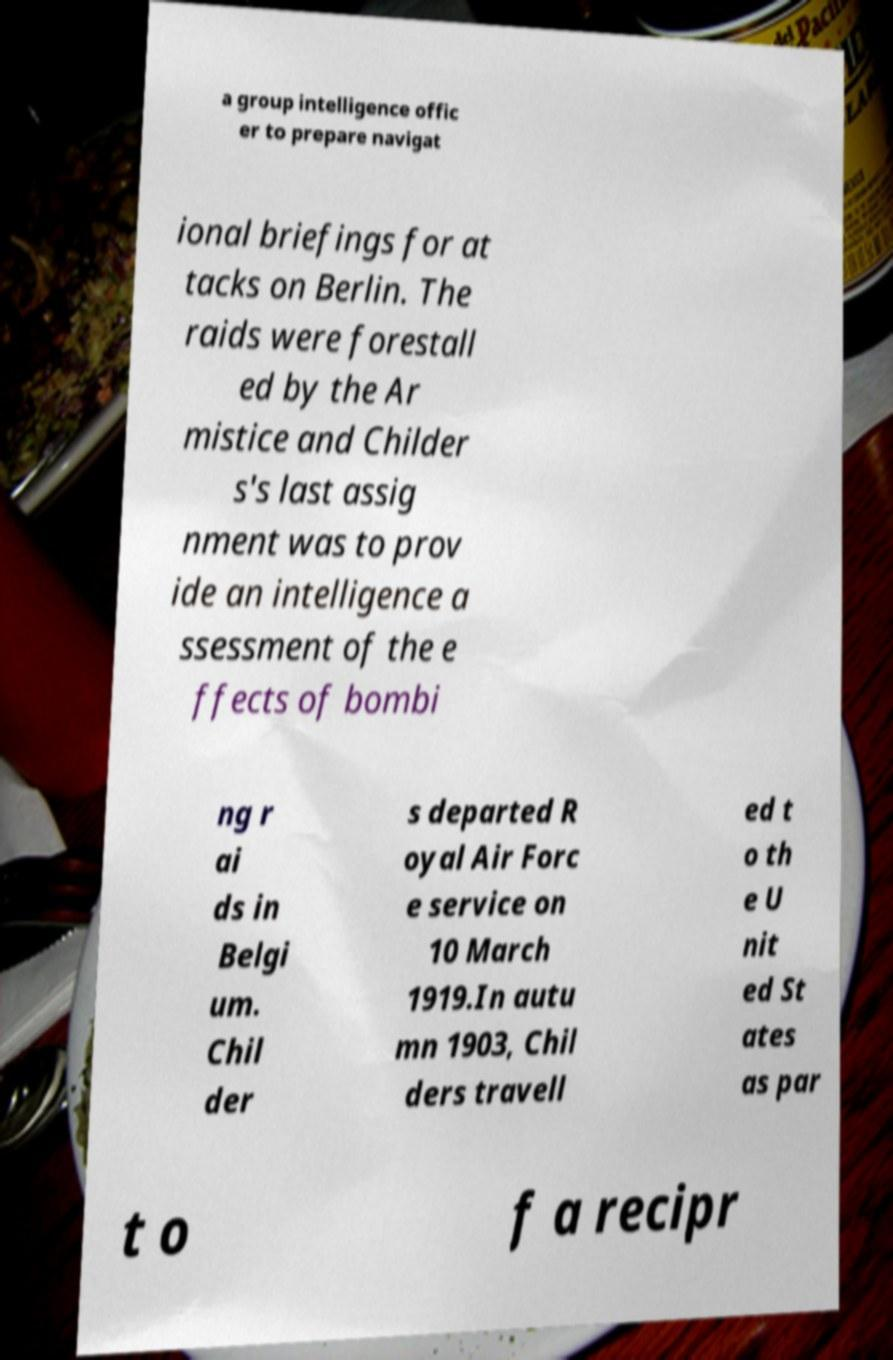Can you read and provide the text displayed in the image?This photo seems to have some interesting text. Can you extract and type it out for me? a group intelligence offic er to prepare navigat ional briefings for at tacks on Berlin. The raids were forestall ed by the Ar mistice and Childer s's last assig nment was to prov ide an intelligence a ssessment of the e ffects of bombi ng r ai ds in Belgi um. Chil der s departed R oyal Air Forc e service on 10 March 1919.In autu mn 1903, Chil ders travell ed t o th e U nit ed St ates as par t o f a recipr 